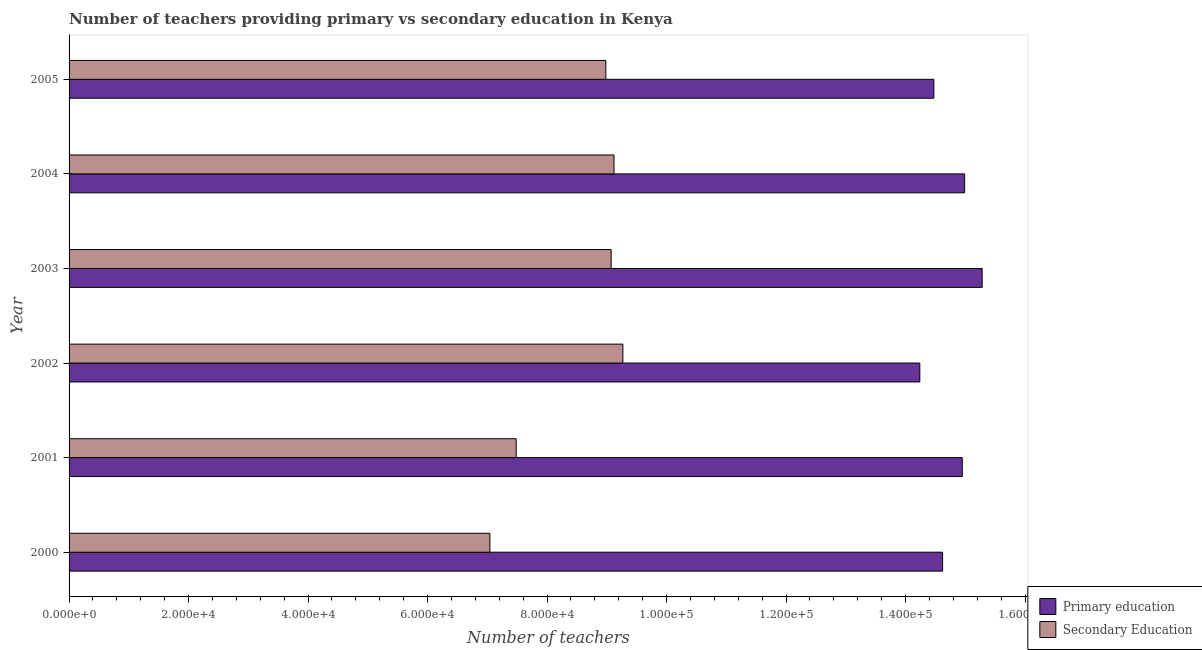How many different coloured bars are there?
Provide a succinct answer. 2. How many groups of bars are there?
Your answer should be very brief. 6. Are the number of bars on each tick of the Y-axis equal?
Make the answer very short. Yes. What is the label of the 5th group of bars from the top?
Make the answer very short. 2001. In how many cases, is the number of bars for a given year not equal to the number of legend labels?
Give a very brief answer. 0. What is the number of secondary teachers in 2001?
Keep it short and to the point. 7.48e+04. Across all years, what is the maximum number of secondary teachers?
Ensure brevity in your answer.  9.27e+04. Across all years, what is the minimum number of secondary teachers?
Give a very brief answer. 7.04e+04. What is the total number of secondary teachers in the graph?
Your answer should be compact. 5.10e+05. What is the difference between the number of secondary teachers in 2003 and that in 2004?
Your response must be concise. -479. What is the difference between the number of secondary teachers in 2002 and the number of primary teachers in 2001?
Provide a succinct answer. -5.68e+04. What is the average number of secondary teachers per year?
Your response must be concise. 8.50e+04. In the year 2000, what is the difference between the number of secondary teachers and number of primary teachers?
Make the answer very short. -7.58e+04. What is the ratio of the number of secondary teachers in 2001 to that in 2002?
Offer a terse response. 0.81. What is the difference between the highest and the second highest number of secondary teachers?
Your answer should be compact. 1484. What is the difference between the highest and the lowest number of primary teachers?
Give a very brief answer. 1.04e+04. In how many years, is the number of secondary teachers greater than the average number of secondary teachers taken over all years?
Your response must be concise. 4. Is the sum of the number of primary teachers in 2003 and 2005 greater than the maximum number of secondary teachers across all years?
Ensure brevity in your answer.  Yes. What does the 1st bar from the top in 2003 represents?
Offer a very short reply. Secondary Education. What does the 1st bar from the bottom in 2005 represents?
Offer a terse response. Primary education. How many bars are there?
Your answer should be very brief. 12. Are all the bars in the graph horizontal?
Offer a terse response. Yes. What is the difference between two consecutive major ticks on the X-axis?
Give a very brief answer. 2.00e+04. Are the values on the major ticks of X-axis written in scientific E-notation?
Offer a very short reply. Yes. Does the graph contain any zero values?
Your answer should be compact. No. How are the legend labels stacked?
Ensure brevity in your answer.  Vertical. What is the title of the graph?
Your answer should be compact. Number of teachers providing primary vs secondary education in Kenya. What is the label or title of the X-axis?
Provide a short and direct response. Number of teachers. What is the Number of teachers of Primary education in 2000?
Keep it short and to the point. 1.46e+05. What is the Number of teachers in Secondary Education in 2000?
Offer a terse response. 7.04e+04. What is the Number of teachers of Primary education in 2001?
Offer a very short reply. 1.50e+05. What is the Number of teachers in Secondary Education in 2001?
Your answer should be very brief. 7.48e+04. What is the Number of teachers of Primary education in 2002?
Give a very brief answer. 1.42e+05. What is the Number of teachers in Secondary Education in 2002?
Offer a terse response. 9.27e+04. What is the Number of teachers of Primary education in 2003?
Offer a very short reply. 1.53e+05. What is the Number of teachers in Secondary Education in 2003?
Your answer should be very brief. 9.07e+04. What is the Number of teachers in Primary education in 2004?
Ensure brevity in your answer.  1.50e+05. What is the Number of teachers of Secondary Education in 2004?
Your answer should be very brief. 9.12e+04. What is the Number of teachers of Primary education in 2005?
Offer a terse response. 1.45e+05. What is the Number of teachers in Secondary Education in 2005?
Your answer should be compact. 8.98e+04. Across all years, what is the maximum Number of teachers of Primary education?
Keep it short and to the point. 1.53e+05. Across all years, what is the maximum Number of teachers in Secondary Education?
Your answer should be very brief. 9.27e+04. Across all years, what is the minimum Number of teachers of Primary education?
Keep it short and to the point. 1.42e+05. Across all years, what is the minimum Number of teachers in Secondary Education?
Offer a terse response. 7.04e+04. What is the total Number of teachers in Primary education in the graph?
Give a very brief answer. 8.86e+05. What is the total Number of teachers of Secondary Education in the graph?
Make the answer very short. 5.10e+05. What is the difference between the Number of teachers of Primary education in 2000 and that in 2001?
Make the answer very short. -3296. What is the difference between the Number of teachers in Secondary Education in 2000 and that in 2001?
Give a very brief answer. -4407. What is the difference between the Number of teachers in Primary education in 2000 and that in 2002?
Give a very brief answer. 3813. What is the difference between the Number of teachers in Secondary Education in 2000 and that in 2002?
Provide a succinct answer. -2.23e+04. What is the difference between the Number of teachers of Primary education in 2000 and that in 2003?
Your response must be concise. -6623. What is the difference between the Number of teachers of Secondary Education in 2000 and that in 2003?
Offer a terse response. -2.03e+04. What is the difference between the Number of teachers of Primary education in 2000 and that in 2004?
Your response must be concise. -3688. What is the difference between the Number of teachers in Secondary Education in 2000 and that in 2004?
Your answer should be very brief. -2.08e+04. What is the difference between the Number of teachers of Primary education in 2000 and that in 2005?
Offer a very short reply. 1461. What is the difference between the Number of teachers of Secondary Education in 2000 and that in 2005?
Give a very brief answer. -1.94e+04. What is the difference between the Number of teachers in Primary education in 2001 and that in 2002?
Provide a short and direct response. 7109. What is the difference between the Number of teachers of Secondary Education in 2001 and that in 2002?
Keep it short and to the point. -1.79e+04. What is the difference between the Number of teachers of Primary education in 2001 and that in 2003?
Give a very brief answer. -3327. What is the difference between the Number of teachers of Secondary Education in 2001 and that in 2003?
Keep it short and to the point. -1.59e+04. What is the difference between the Number of teachers of Primary education in 2001 and that in 2004?
Your answer should be very brief. -392. What is the difference between the Number of teachers in Secondary Education in 2001 and that in 2004?
Give a very brief answer. -1.64e+04. What is the difference between the Number of teachers of Primary education in 2001 and that in 2005?
Your answer should be very brief. 4757. What is the difference between the Number of teachers in Secondary Education in 2001 and that in 2005?
Ensure brevity in your answer.  -1.50e+04. What is the difference between the Number of teachers of Primary education in 2002 and that in 2003?
Keep it short and to the point. -1.04e+04. What is the difference between the Number of teachers of Secondary Education in 2002 and that in 2003?
Your answer should be very brief. 1963. What is the difference between the Number of teachers in Primary education in 2002 and that in 2004?
Ensure brevity in your answer.  -7501. What is the difference between the Number of teachers in Secondary Education in 2002 and that in 2004?
Your response must be concise. 1484. What is the difference between the Number of teachers of Primary education in 2002 and that in 2005?
Make the answer very short. -2352. What is the difference between the Number of teachers in Secondary Education in 2002 and that in 2005?
Provide a short and direct response. 2853. What is the difference between the Number of teachers in Primary education in 2003 and that in 2004?
Offer a very short reply. 2935. What is the difference between the Number of teachers of Secondary Education in 2003 and that in 2004?
Offer a terse response. -479. What is the difference between the Number of teachers in Primary education in 2003 and that in 2005?
Ensure brevity in your answer.  8084. What is the difference between the Number of teachers in Secondary Education in 2003 and that in 2005?
Provide a succinct answer. 890. What is the difference between the Number of teachers of Primary education in 2004 and that in 2005?
Make the answer very short. 5149. What is the difference between the Number of teachers of Secondary Education in 2004 and that in 2005?
Give a very brief answer. 1369. What is the difference between the Number of teachers in Primary education in 2000 and the Number of teachers in Secondary Education in 2001?
Offer a terse response. 7.14e+04. What is the difference between the Number of teachers in Primary education in 2000 and the Number of teachers in Secondary Education in 2002?
Give a very brief answer. 5.35e+04. What is the difference between the Number of teachers in Primary education in 2000 and the Number of teachers in Secondary Education in 2003?
Offer a terse response. 5.55e+04. What is the difference between the Number of teachers of Primary education in 2000 and the Number of teachers of Secondary Education in 2004?
Ensure brevity in your answer.  5.50e+04. What is the difference between the Number of teachers in Primary education in 2000 and the Number of teachers in Secondary Education in 2005?
Your answer should be very brief. 5.64e+04. What is the difference between the Number of teachers of Primary education in 2001 and the Number of teachers of Secondary Education in 2002?
Your answer should be compact. 5.68e+04. What is the difference between the Number of teachers of Primary education in 2001 and the Number of teachers of Secondary Education in 2003?
Offer a very short reply. 5.88e+04. What is the difference between the Number of teachers of Primary education in 2001 and the Number of teachers of Secondary Education in 2004?
Offer a very short reply. 5.83e+04. What is the difference between the Number of teachers of Primary education in 2001 and the Number of teachers of Secondary Education in 2005?
Provide a short and direct response. 5.97e+04. What is the difference between the Number of teachers of Primary education in 2002 and the Number of teachers of Secondary Education in 2003?
Your response must be concise. 5.17e+04. What is the difference between the Number of teachers in Primary education in 2002 and the Number of teachers in Secondary Education in 2004?
Keep it short and to the point. 5.12e+04. What is the difference between the Number of teachers in Primary education in 2002 and the Number of teachers in Secondary Education in 2005?
Offer a terse response. 5.26e+04. What is the difference between the Number of teachers of Primary education in 2003 and the Number of teachers of Secondary Education in 2004?
Provide a succinct answer. 6.16e+04. What is the difference between the Number of teachers in Primary education in 2003 and the Number of teachers in Secondary Education in 2005?
Ensure brevity in your answer.  6.30e+04. What is the difference between the Number of teachers in Primary education in 2004 and the Number of teachers in Secondary Education in 2005?
Offer a very short reply. 6.01e+04. What is the average Number of teachers of Primary education per year?
Your response must be concise. 1.48e+05. What is the average Number of teachers of Secondary Education per year?
Provide a succinct answer. 8.50e+04. In the year 2000, what is the difference between the Number of teachers of Primary education and Number of teachers of Secondary Education?
Offer a terse response. 7.58e+04. In the year 2001, what is the difference between the Number of teachers of Primary education and Number of teachers of Secondary Education?
Make the answer very short. 7.47e+04. In the year 2002, what is the difference between the Number of teachers in Primary education and Number of teachers in Secondary Education?
Offer a very short reply. 4.97e+04. In the year 2003, what is the difference between the Number of teachers in Primary education and Number of teachers in Secondary Education?
Provide a succinct answer. 6.21e+04. In the year 2004, what is the difference between the Number of teachers in Primary education and Number of teachers in Secondary Education?
Your response must be concise. 5.87e+04. In the year 2005, what is the difference between the Number of teachers of Primary education and Number of teachers of Secondary Education?
Make the answer very short. 5.49e+04. What is the ratio of the Number of teachers in Secondary Education in 2000 to that in 2001?
Offer a very short reply. 0.94. What is the ratio of the Number of teachers in Primary education in 2000 to that in 2002?
Make the answer very short. 1.03. What is the ratio of the Number of teachers in Secondary Education in 2000 to that in 2002?
Ensure brevity in your answer.  0.76. What is the ratio of the Number of teachers in Primary education in 2000 to that in 2003?
Your answer should be compact. 0.96. What is the ratio of the Number of teachers of Secondary Education in 2000 to that in 2003?
Your response must be concise. 0.78. What is the ratio of the Number of teachers in Primary education in 2000 to that in 2004?
Provide a succinct answer. 0.98. What is the ratio of the Number of teachers in Secondary Education in 2000 to that in 2004?
Your response must be concise. 0.77. What is the ratio of the Number of teachers of Primary education in 2000 to that in 2005?
Ensure brevity in your answer.  1.01. What is the ratio of the Number of teachers of Secondary Education in 2000 to that in 2005?
Keep it short and to the point. 0.78. What is the ratio of the Number of teachers of Primary education in 2001 to that in 2002?
Ensure brevity in your answer.  1.05. What is the ratio of the Number of teachers in Secondary Education in 2001 to that in 2002?
Give a very brief answer. 0.81. What is the ratio of the Number of teachers in Primary education in 2001 to that in 2003?
Ensure brevity in your answer.  0.98. What is the ratio of the Number of teachers of Secondary Education in 2001 to that in 2003?
Offer a terse response. 0.82. What is the ratio of the Number of teachers in Primary education in 2001 to that in 2004?
Provide a succinct answer. 1. What is the ratio of the Number of teachers of Secondary Education in 2001 to that in 2004?
Your answer should be very brief. 0.82. What is the ratio of the Number of teachers in Primary education in 2001 to that in 2005?
Keep it short and to the point. 1.03. What is the ratio of the Number of teachers of Secondary Education in 2001 to that in 2005?
Offer a very short reply. 0.83. What is the ratio of the Number of teachers in Primary education in 2002 to that in 2003?
Ensure brevity in your answer.  0.93. What is the ratio of the Number of teachers of Secondary Education in 2002 to that in 2003?
Give a very brief answer. 1.02. What is the ratio of the Number of teachers of Secondary Education in 2002 to that in 2004?
Give a very brief answer. 1.02. What is the ratio of the Number of teachers of Primary education in 2002 to that in 2005?
Keep it short and to the point. 0.98. What is the ratio of the Number of teachers in Secondary Education in 2002 to that in 2005?
Your answer should be compact. 1.03. What is the ratio of the Number of teachers in Primary education in 2003 to that in 2004?
Your answer should be compact. 1.02. What is the ratio of the Number of teachers of Primary education in 2003 to that in 2005?
Make the answer very short. 1.06. What is the ratio of the Number of teachers in Secondary Education in 2003 to that in 2005?
Provide a succinct answer. 1.01. What is the ratio of the Number of teachers in Primary education in 2004 to that in 2005?
Keep it short and to the point. 1.04. What is the ratio of the Number of teachers in Secondary Education in 2004 to that in 2005?
Provide a succinct answer. 1.02. What is the difference between the highest and the second highest Number of teachers of Primary education?
Your response must be concise. 2935. What is the difference between the highest and the second highest Number of teachers of Secondary Education?
Your response must be concise. 1484. What is the difference between the highest and the lowest Number of teachers in Primary education?
Give a very brief answer. 1.04e+04. What is the difference between the highest and the lowest Number of teachers of Secondary Education?
Provide a short and direct response. 2.23e+04. 